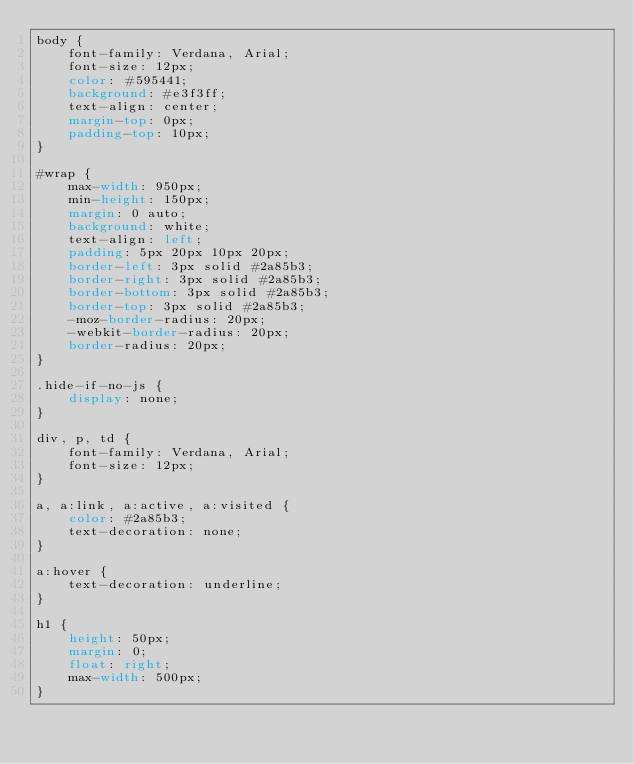<code> <loc_0><loc_0><loc_500><loc_500><_CSS_>body {
    font-family: Verdana, Arial;
    font-size: 12px;
    color: #595441;
    background: #e3f3ff;
    text-align: center;
    margin-top: 0px;
    padding-top: 10px;
}

#wrap {
    max-width: 950px;
    min-height: 150px;
    margin: 0 auto;
    background: white;
    text-align: left;
    padding: 5px 20px 10px 20px;
    border-left: 3px solid #2a85b3;
    border-right: 3px solid #2a85b3;
    border-bottom: 3px solid #2a85b3;
    border-top: 3px solid #2a85b3;
    -moz-border-radius: 20px;
    -webkit-border-radius: 20px;
    border-radius: 20px;
}

.hide-if-no-js {
    display: none;
}

div, p, td {
    font-family: Verdana, Arial;
    font-size: 12px;
}

a, a:link, a:active, a:visited {
    color: #2a85b3;
    text-decoration: none;
}

a:hover {
    text-decoration: underline;
}

h1 {
    height: 50px;
    margin: 0;
    float: right;
    max-width: 500px;
}
</code> 